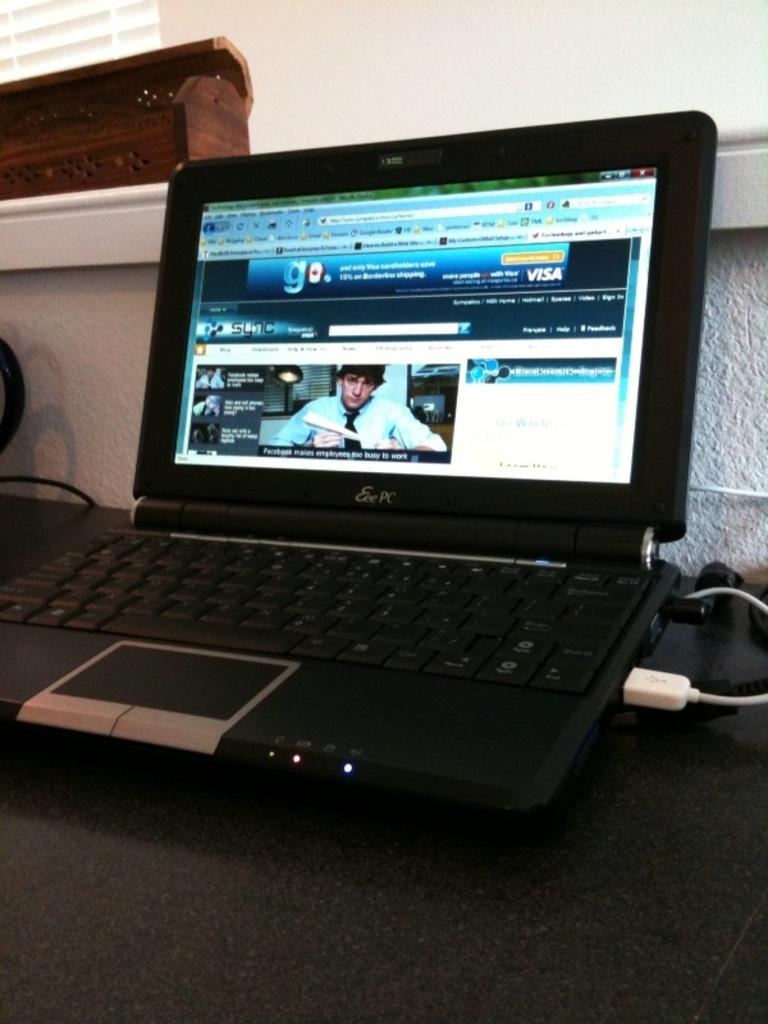<image>
Create a compact narrative representing the image presented. An Eee PC with the Sync website opened on the monitor. 